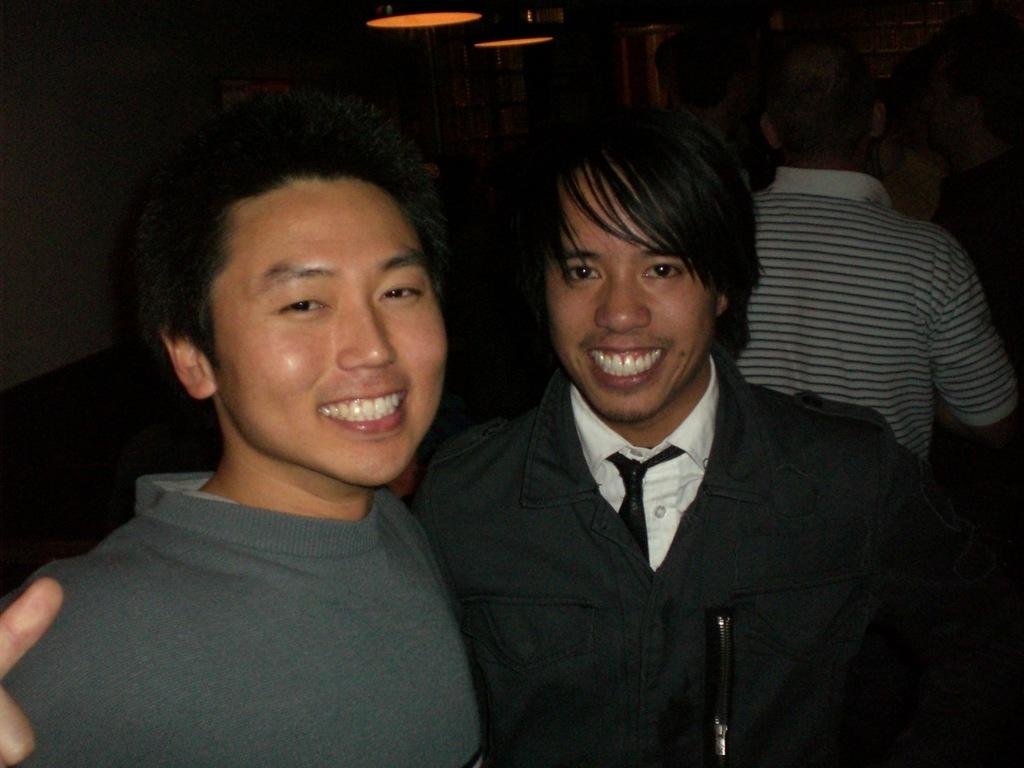What can be observed about the people in the image? There are people standing in the image, and they have smiles on their faces. What is the overall tone or mood of the image? The smiles on the people's faces suggest a positive or happy mood. How would you describe the lighting or brightness of the image? The background of the image is slightly dark. Can you see a circle-shaped object in the image? There is no circle-shaped object mentioned or visible in the image. Are there any pets present in the image? There is no mention or indication of a pet in the image. 